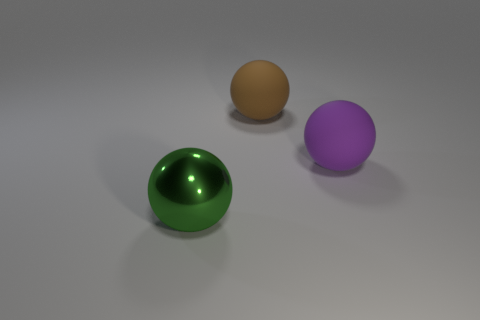Add 3 brown matte things. How many objects exist? 6 Subtract all big rubber spheres. How many spheres are left? 1 Subtract all brown spheres. How many spheres are left? 2 Subtract 2 balls. How many balls are left? 1 Subtract all blue cubes. How many purple balls are left? 1 Subtract all small objects. Subtract all big rubber things. How many objects are left? 1 Add 1 big matte things. How many big matte things are left? 3 Add 1 large yellow cubes. How many large yellow cubes exist? 1 Subtract 1 green spheres. How many objects are left? 2 Subtract all blue balls. Subtract all red cubes. How many balls are left? 3 